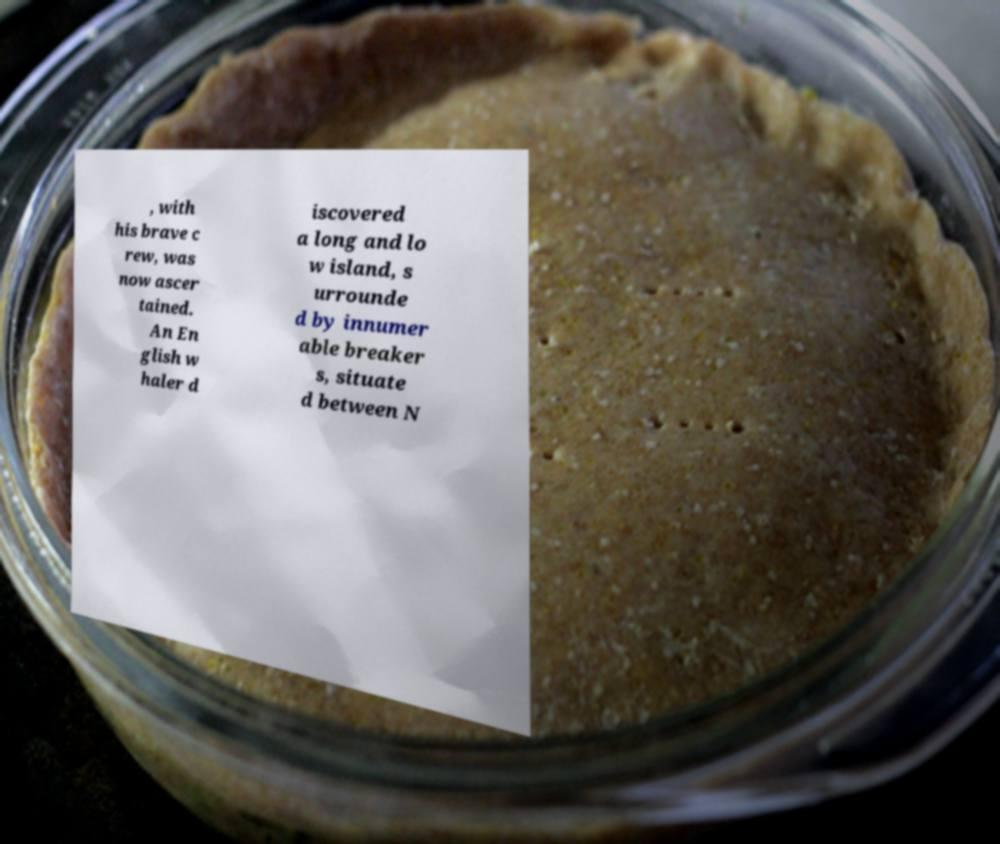Could you assist in decoding the text presented in this image and type it out clearly? , with his brave c rew, was now ascer tained. An En glish w haler d iscovered a long and lo w island, s urrounde d by innumer able breaker s, situate d between N 